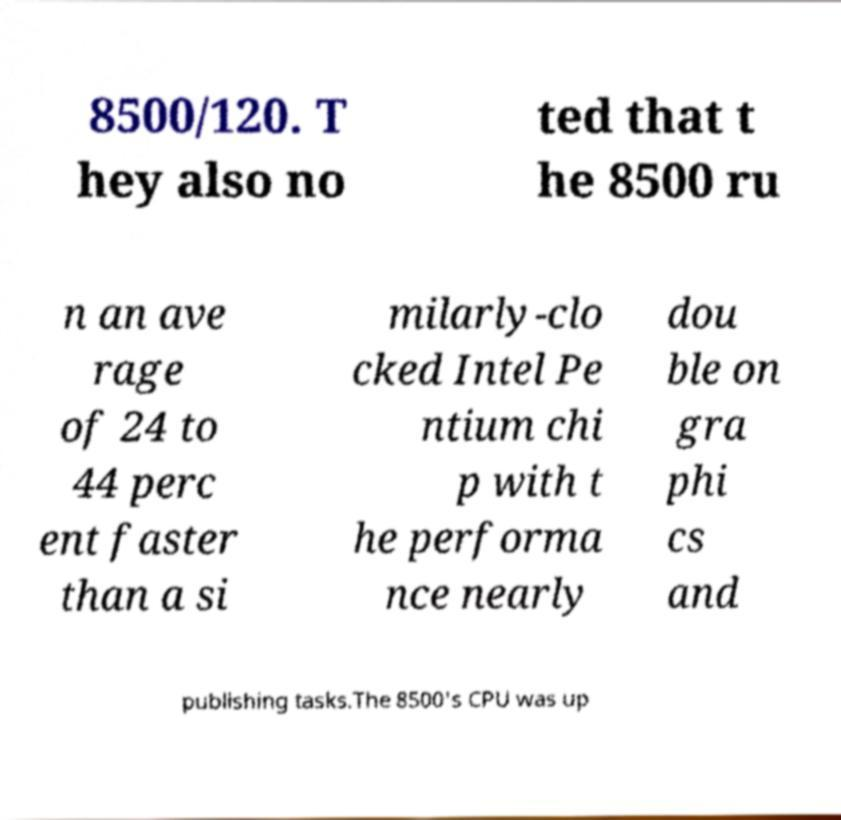Could you assist in decoding the text presented in this image and type it out clearly? 8500/120. T hey also no ted that t he 8500 ru n an ave rage of 24 to 44 perc ent faster than a si milarly-clo cked Intel Pe ntium chi p with t he performa nce nearly dou ble on gra phi cs and publishing tasks.The 8500's CPU was up 